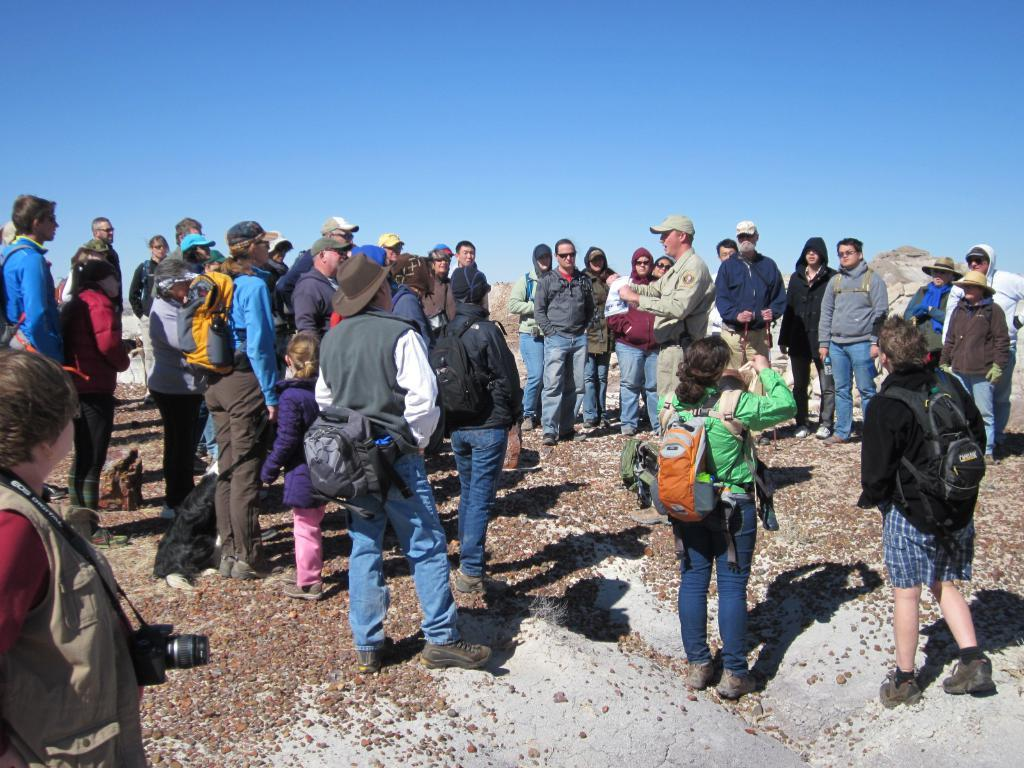What can be seen in the image? There are people standing in the image. What are some of the people wearing? Some people are wearing caps. What are some of the people carrying? Some people are carrying bags. What is visible at the top of the image? The sky is visible at the top of the image. Where is the maid standing in the image? There is no maid present in the image. What type of tray is being used by the people in the image? There is no tray visible in the image. 